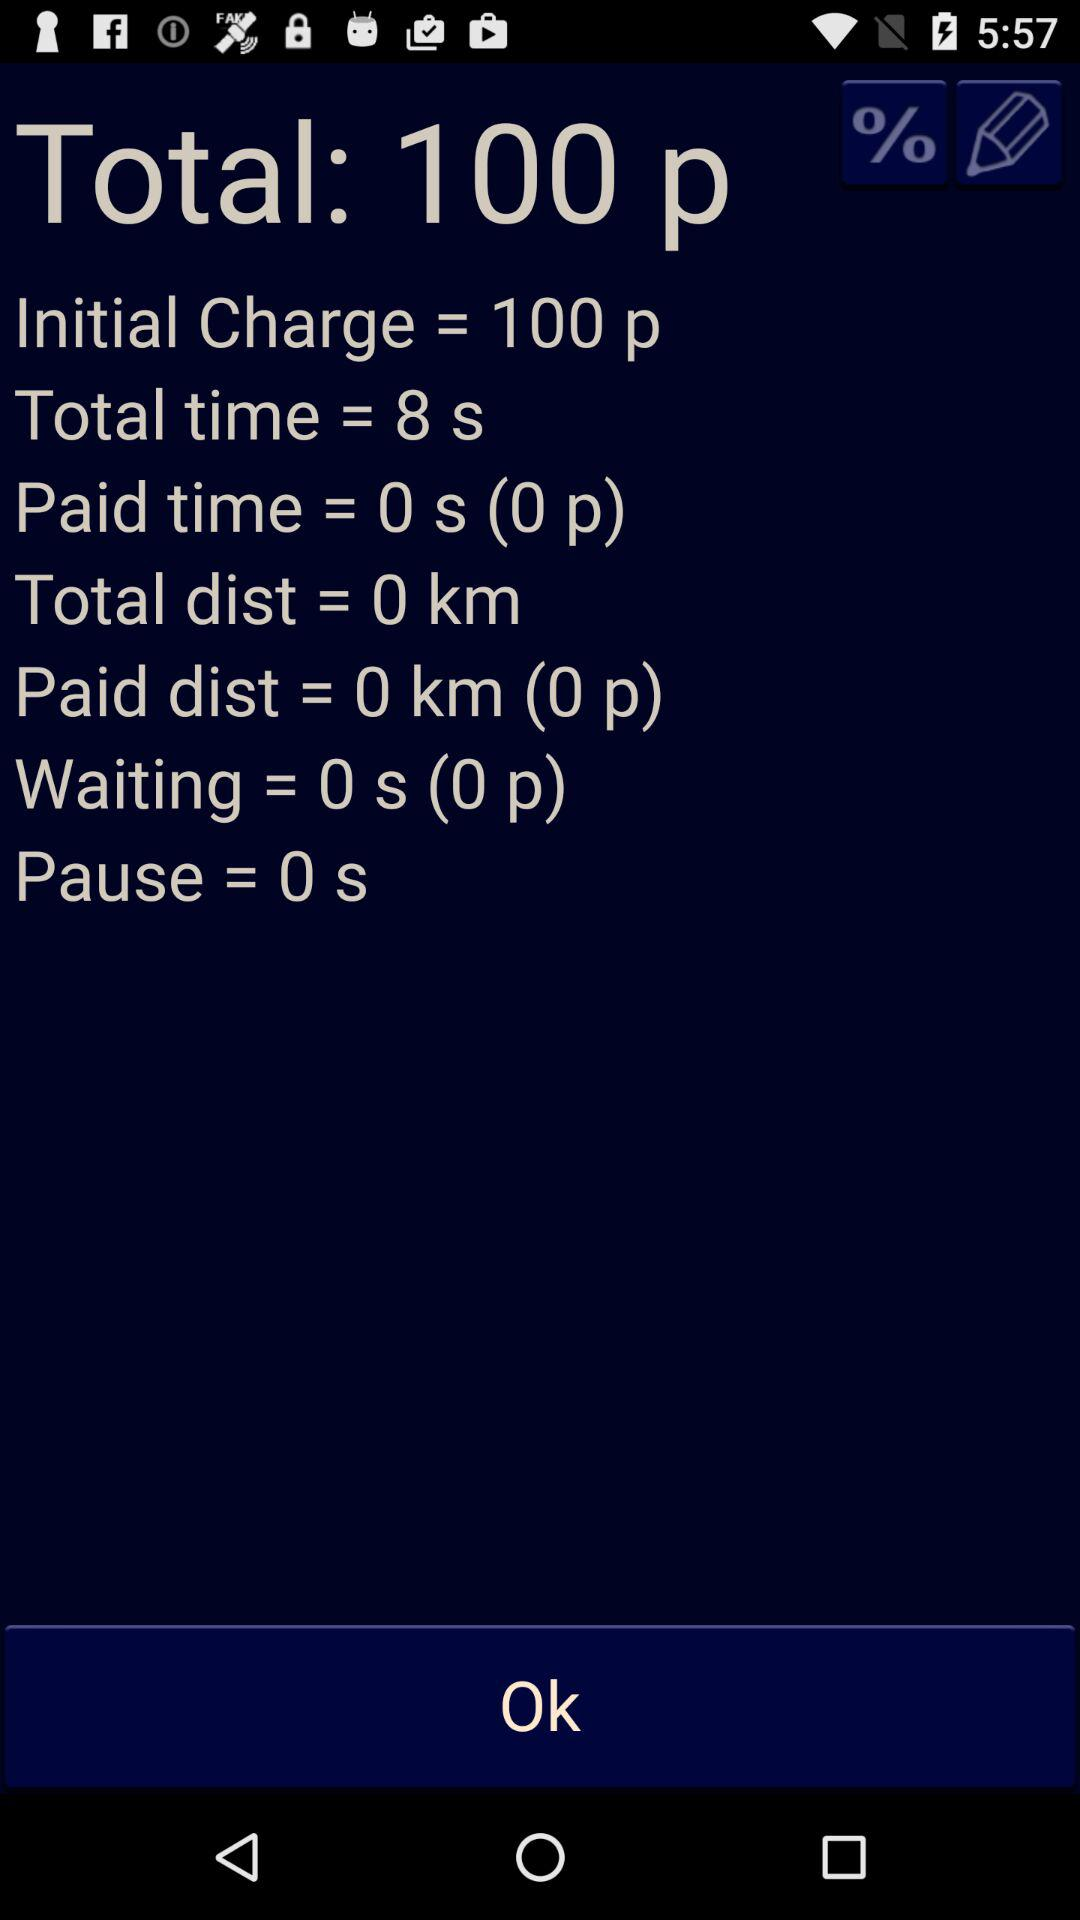How much money has been paid for the ride?
Answer the question using a single word or phrase. 0 p 